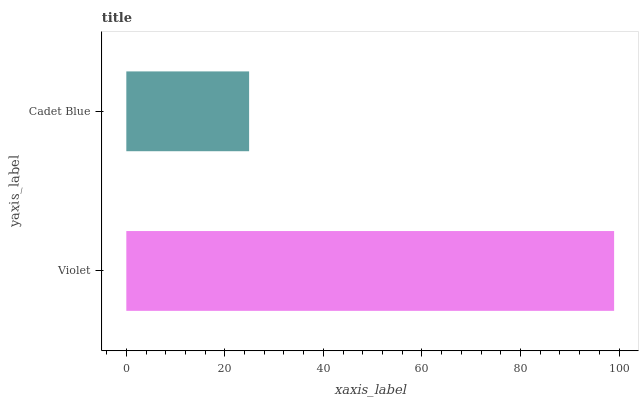Is Cadet Blue the minimum?
Answer yes or no. Yes. Is Violet the maximum?
Answer yes or no. Yes. Is Cadet Blue the maximum?
Answer yes or no. No. Is Violet greater than Cadet Blue?
Answer yes or no. Yes. Is Cadet Blue less than Violet?
Answer yes or no. Yes. Is Cadet Blue greater than Violet?
Answer yes or no. No. Is Violet less than Cadet Blue?
Answer yes or no. No. Is Violet the high median?
Answer yes or no. Yes. Is Cadet Blue the low median?
Answer yes or no. Yes. Is Cadet Blue the high median?
Answer yes or no. No. Is Violet the low median?
Answer yes or no. No. 